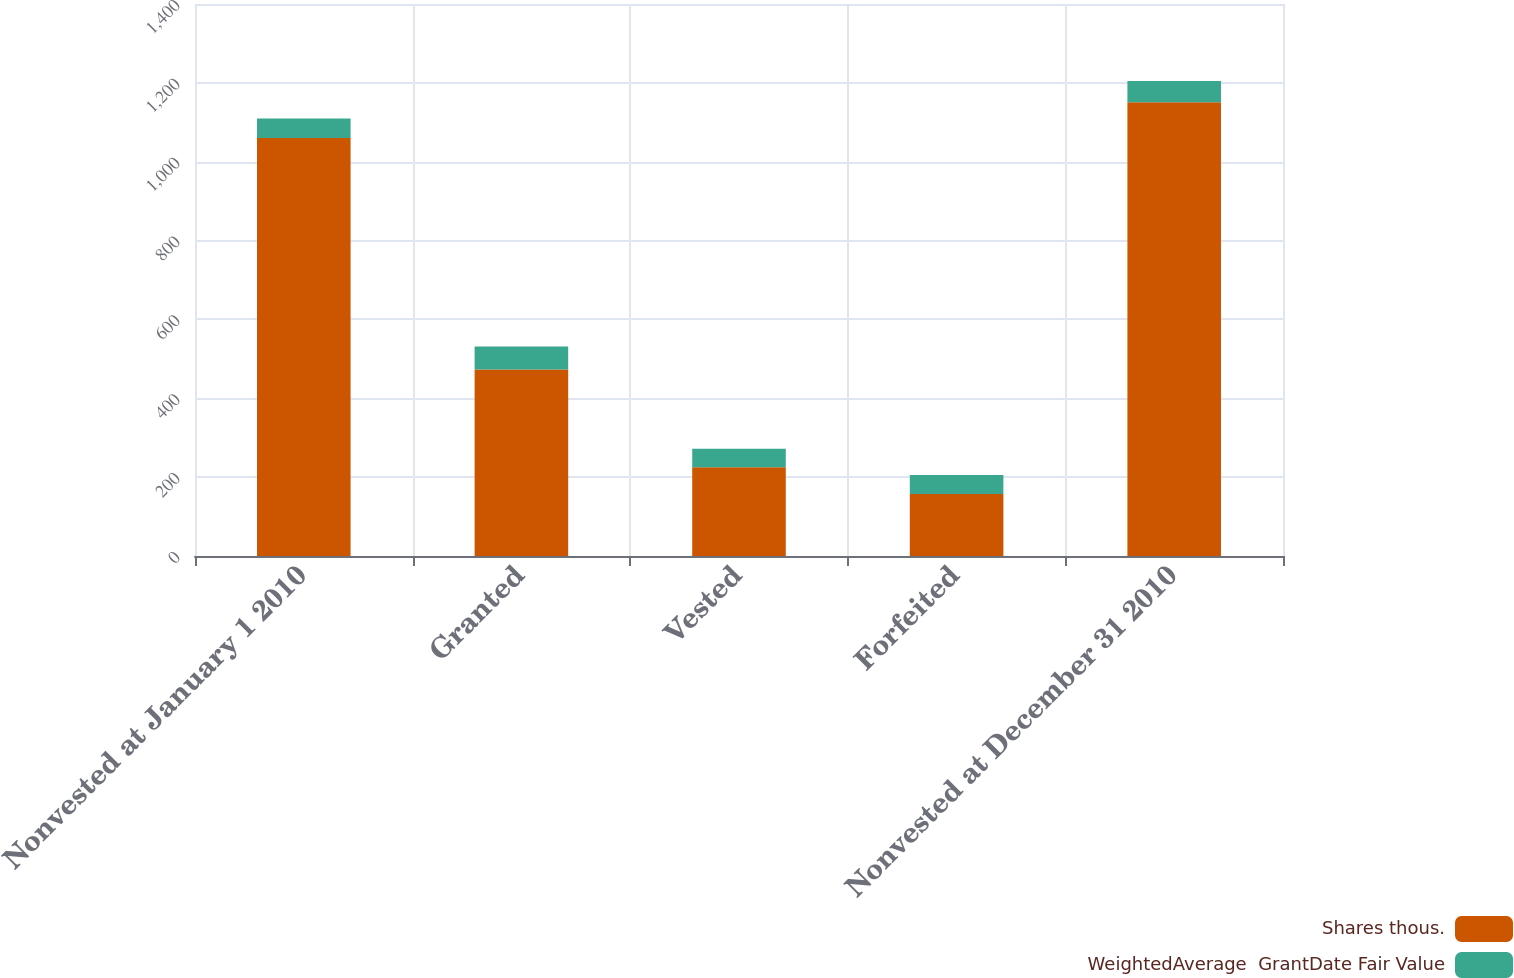Convert chart to OTSL. <chart><loc_0><loc_0><loc_500><loc_500><stacked_bar_chart><ecel><fcel>Nonvested at January 1 2010<fcel>Granted<fcel>Vested<fcel>Forfeited<fcel>Nonvested at December 31 2010<nl><fcel>Shares thous.<fcel>1060<fcel>473<fcel>225<fcel>157<fcel>1151<nl><fcel>WeightedAverage  GrantDate Fair Value<fcel>49.75<fcel>58.33<fcel>47.24<fcel>48.6<fcel>53.93<nl></chart> 